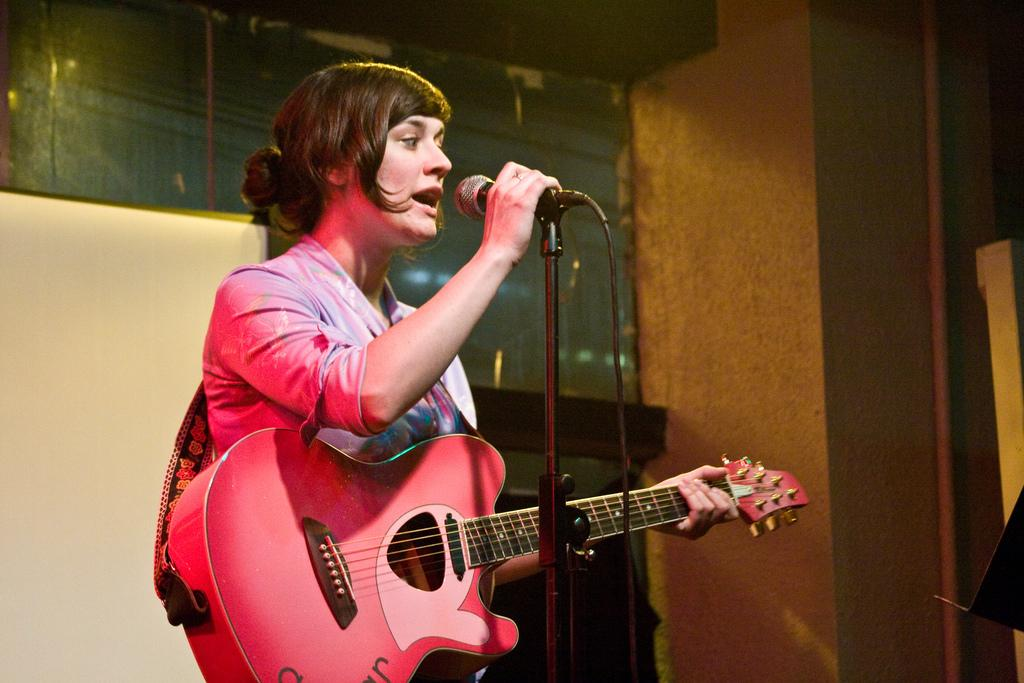What is the person in the image doing? The person is holding a guitar. What might the person be about to do with the guitar? The person might be about to play the guitar. What is in front of the person? There is a microphone in front of the person. What might the person be doing with the microphone? The person might be about to sing or speak into the microphone. What substance is the person using to clean their elbow in the image? There is no substance visible in the image, and the person's elbow is not being cleaned. Can you see a rat in the image? No, there is no rat present in the image. 